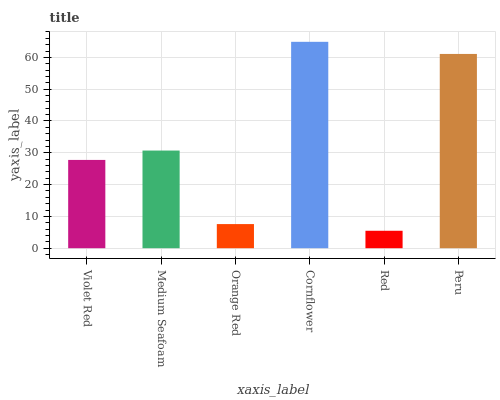Is Red the minimum?
Answer yes or no. Yes. Is Cornflower the maximum?
Answer yes or no. Yes. Is Medium Seafoam the minimum?
Answer yes or no. No. Is Medium Seafoam the maximum?
Answer yes or no. No. Is Medium Seafoam greater than Violet Red?
Answer yes or no. Yes. Is Violet Red less than Medium Seafoam?
Answer yes or no. Yes. Is Violet Red greater than Medium Seafoam?
Answer yes or no. No. Is Medium Seafoam less than Violet Red?
Answer yes or no. No. Is Medium Seafoam the high median?
Answer yes or no. Yes. Is Violet Red the low median?
Answer yes or no. Yes. Is Orange Red the high median?
Answer yes or no. No. Is Peru the low median?
Answer yes or no. No. 